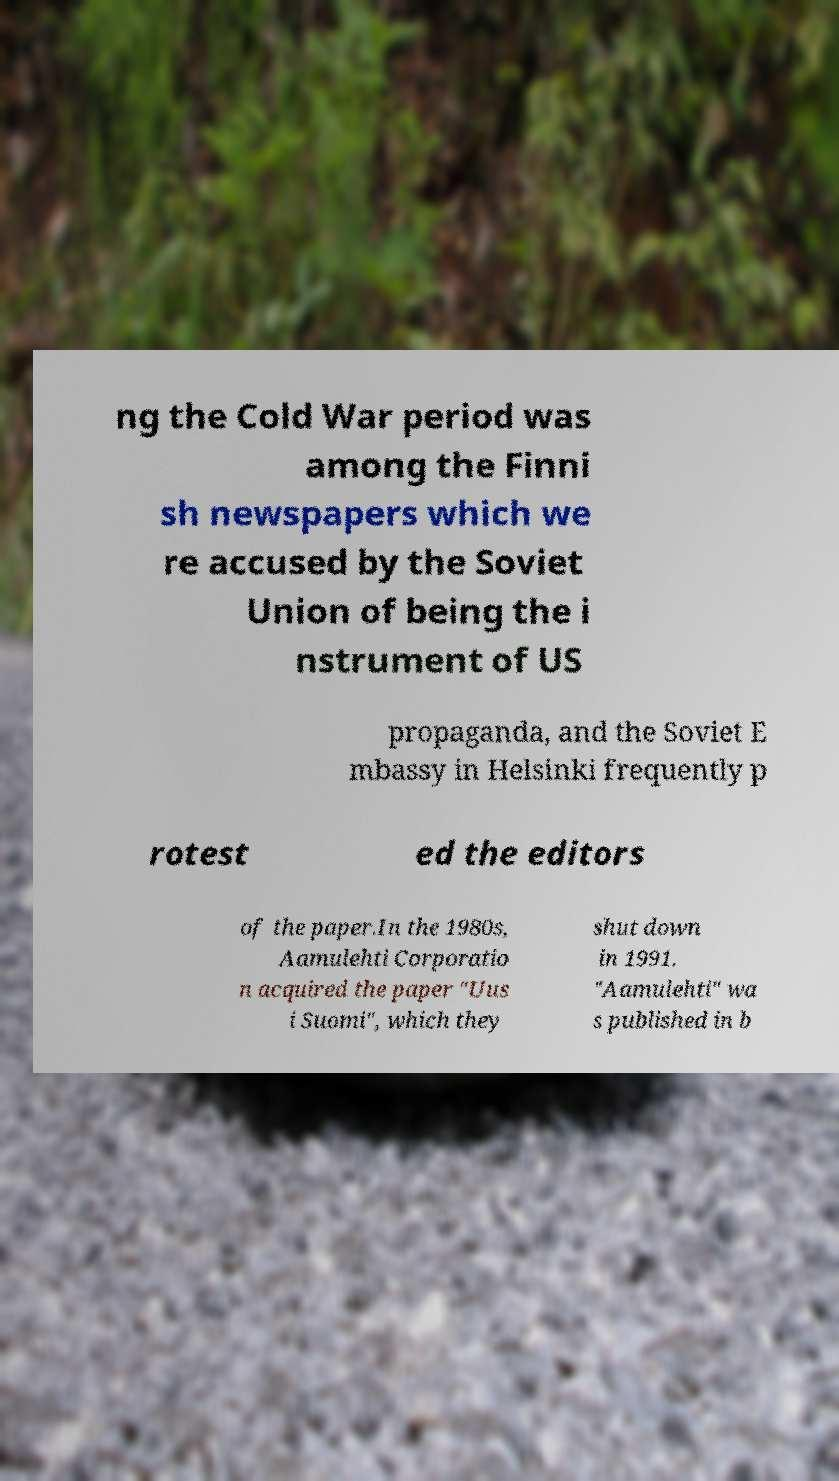Could you extract and type out the text from this image? ng the Cold War period was among the Finni sh newspapers which we re accused by the Soviet Union of being the i nstrument of US propaganda, and the Soviet E mbassy in Helsinki frequently p rotest ed the editors of the paper.In the 1980s, Aamulehti Corporatio n acquired the paper "Uus i Suomi", which they shut down in 1991. "Aamulehti" wa s published in b 